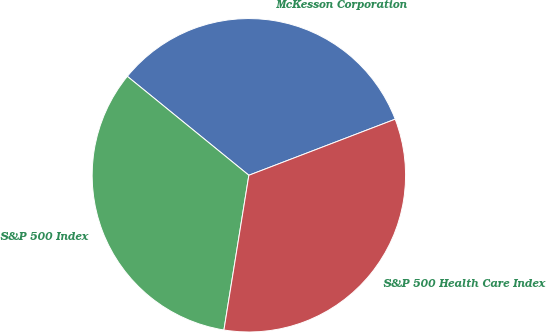<chart> <loc_0><loc_0><loc_500><loc_500><pie_chart><fcel>McKesson Corporation<fcel>S&P 500 Index<fcel>S&P 500 Health Care Index<nl><fcel>33.3%<fcel>33.33%<fcel>33.37%<nl></chart> 